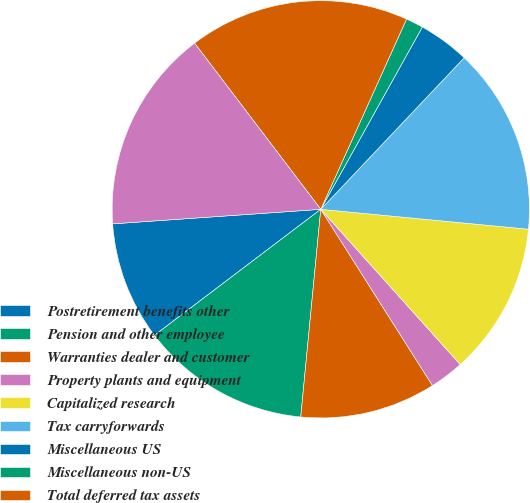Convert chart to OTSL. <chart><loc_0><loc_0><loc_500><loc_500><pie_chart><fcel>Postretirement benefits other<fcel>Pension and other employee<fcel>Warranties dealer and customer<fcel>Property plants and equipment<fcel>Capitalized research<fcel>Tax carryforwards<fcel>Miscellaneous US<fcel>Miscellaneous non-US<fcel>Total deferred tax assets<fcel>Less Valuation allowances<nl><fcel>9.21%<fcel>13.15%<fcel>10.52%<fcel>2.66%<fcel>11.83%<fcel>14.46%<fcel>3.97%<fcel>1.35%<fcel>17.08%<fcel>15.77%<nl></chart> 